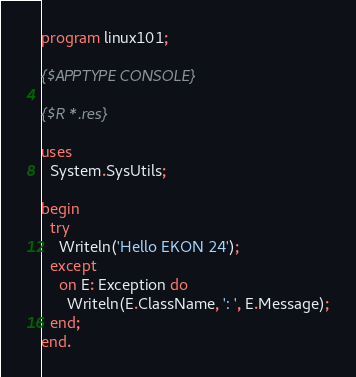Convert code to text. <code><loc_0><loc_0><loc_500><loc_500><_Pascal_>program linux101;

{$APPTYPE CONSOLE}

{$R *.res}

uses
  System.SysUtils;

begin
  try
    Writeln('Hello EKON 24');
  except
    on E: Exception do
      Writeln(E.ClassName, ': ', E.Message);
  end;
end.
</code> 